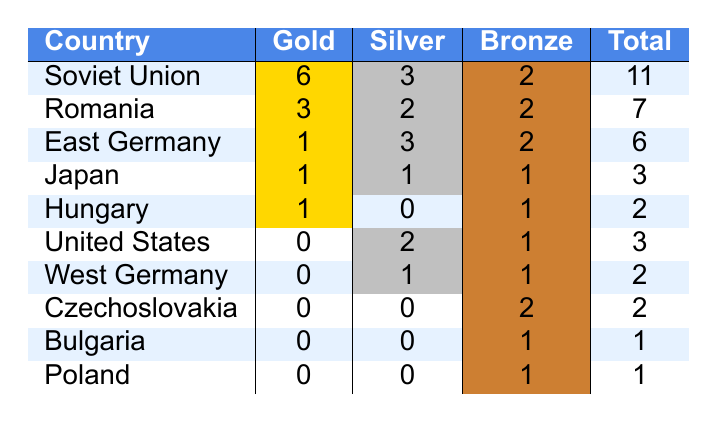What country won the most gold medals in gymnastics at the 1976 Montreal Olympics? The table shows that the Soviet Union won 6 gold medals, which is the highest compared to other countries.
Answer: Soviet Union How many total medals did Romania win in gymnastics? Romania is listed with a total of 7 medals (3 gold, 2 silver, 2 bronze) according to the table.
Answer: 7 Which country earned more silver medals: East Germany or Japan? East Germany is shown with 3 silver medals, while Japan has only 1. Therefore, East Germany earned more silver medals.
Answer: East Germany What is the total number of medals won by the United States? The table displays that the United States won a total of 3 medals in gymnastics (0 gold, 2 silver, and 1 bronze).
Answer: 3 How many bronze medals were won by the countries that did not win any gold medals? The countries without gold medals are the United States, West Germany, Czechoslovakia, Bulgaria, and Poland. Adding their bronze medals (1 + 1 + 2 + 1 + 1) gives a total of 6 bronze medals.
Answer: 6 What is the combined total of gold medals won by Romania and East Germany? Romania won 3 gold medals and East Germany won 1. Thus, the combined total is (3 + 1 = 4).
Answer: 4 Does any country have an equal number of total medals? Yes, both Hungary and West Germany have a total of 2 medals each (1 gold, 0 silver, and 1 bronze for Hungary; 0 gold, 1 silver, and 1 bronze for West Germany).
Answer: Yes Which country had the least overall medals in gymnastics? According to the table, Bulgaria and Poland both have 1 total medal, which is the least among all listed countries.
Answer: Bulgaria and Poland How many bronze medals did the top three countries win in total? Adding the bronze medals for the top three countries: Soviet Union (2), Romania (2), and East Germany (2) gives a total of (2 + 2 + 2 = 6) bronze medals.
Answer: 6 Is there any country that won more silver medals than gold? Yes, East Germany won 3 silver medals, while they only won 1 gold medal.
Answer: Yes 